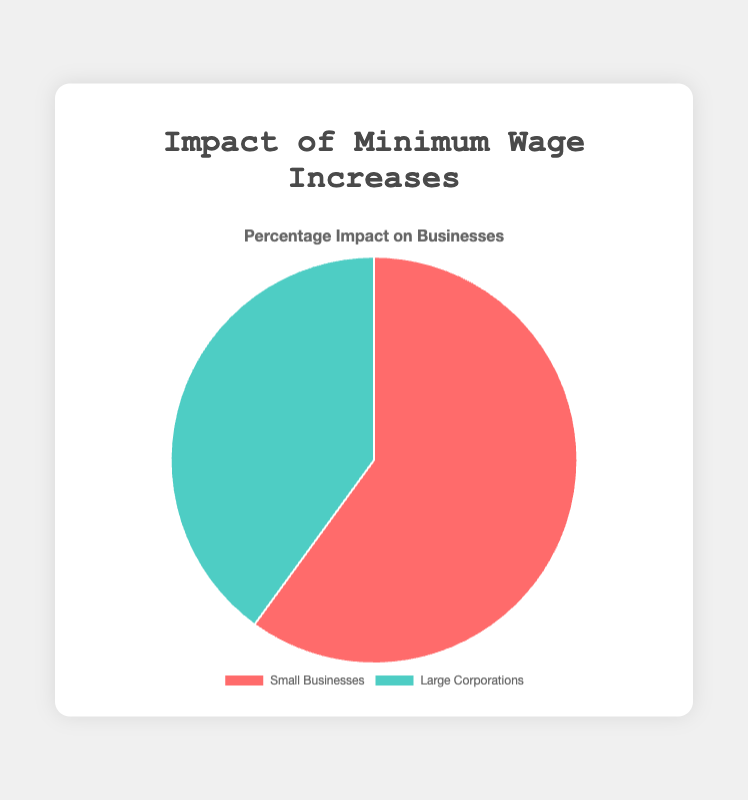What percentage of the impact on businesses comes from small businesses? The chart shows two segments labeled 'Small Businesses' and 'Large Corporations'. According to the chart, 'Small Businesses' account for 60% of the impact.
Answer: 60% What is the combined percentage impact of small businesses and large corporations? The chart indicates that the impact on small businesses is 60%, and on large corporations is 40%. Adding these percentages gives the total impact: 60% + 40% = 100%.
Answer: 100% Which group is more affected by the minimum wage increases? By examining the chart, the segment representing 'Small Businesses' appears larger, indicating a higher impact percentage (60%) compared to 'Large Corporations' (40%).
Answer: Small Businesses By how much percentage is the impact on small businesses higher than that on large corporations? The chart shows that small businesses are impacted by 60%, while large corporations are impacted by 40%. The difference in percentage impact is 60% - 40% = 20%.
Answer: 20% What color represents the impact on large corporations? The chart uses distinct colors for each segment. The segment for 'Large Corporations' is colored green.
Answer: Green What is the ratio of the impact on small businesses to that on large corporations? Small businesses have an impact of 60%, and large corporations have 40%. The ratio is 60:40, which simplifies to 3:2.
Answer: 3:2 What portion of the pie chart does the impact on large corporations represent? The pie chart for 'Large Corporations' represents 40%, which is less than half of the chart.
Answer: 40% Is the impact on small businesses less than, equal to, or greater than that on large corporations? From the chart, the segment for 'Small Businesses' (60%) is visibly larger than that for 'Large Corporations' (40%).
Answer: Greater than Which group has a smaller impact percentage-wise? The visual size of the pie chart segment and the numerical data both indicate that 'Large Corporations' have a smaller impact percentage (40%) compared to 'Small Businesses' (60%).
Answer: Large Corporations 